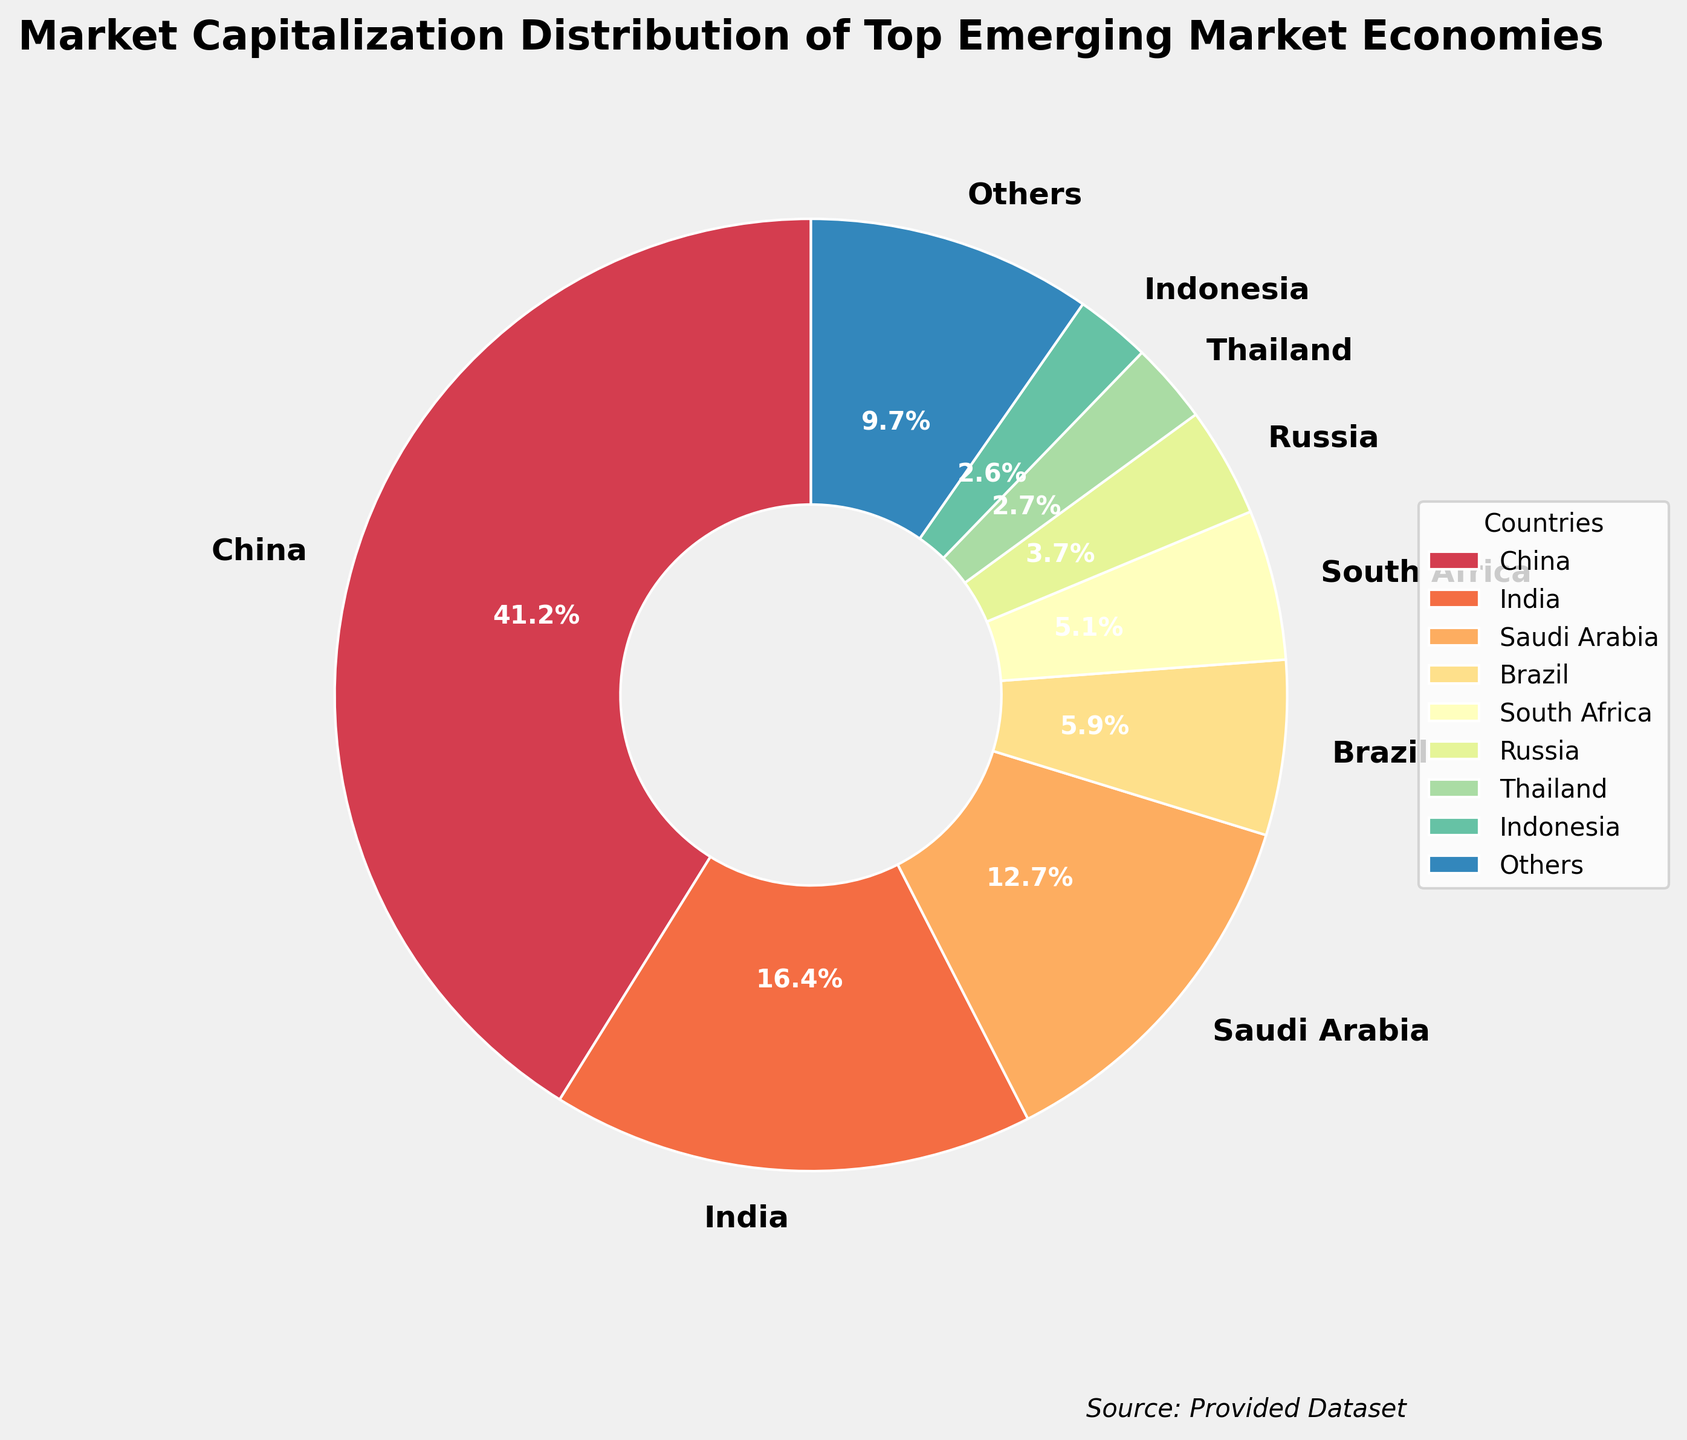What's the total percentage represented by China and India? China represents 40.5% and India represents 16.1%. Adding these percentages together: 40.5% + 16.1% = 56.6%.
Answer: 56.6% Which country has the smallest share among the top 8 countries? The country with the smallest share among the top 8 is Indonesia, which represents 2.5%. By checking the pie chart, this is clearly seen from the labeled percentages.
Answer: Indonesia How does Brazil's market capitalization compare to that of Saudi Arabia? Brazil's market capitalization is 5.8%, while Saudi Arabia's is 12.5%. Therefore, Saudi Arabia has more than double the percentage of Brazil's market capitalization.
Answer: Saudi Arabia is greater What percentage do the 'Others' category account for? By summing up the percentages of the top 8 countries and subtracting from 100%, we find 'Others'. Adding these values: 40.5% (China) + 16.1% (India) + 12.5% (Saudi Arabia) + 5.8% (Brazil) + 4.9% (South Africa) + 3.7% (Russia) + 2.5% (Indonesia) + 2.3% (Thailand) gives 88.3%. So, 100% - 88.3% = 11.7%.
Answer: 11.7% Identify the country represented by the second largest segment in the pie chart The second-largest segment in the pie chart corresponds to India, which accounts for 16.1% of the market capitalization among the top emerging market economies.
Answer: India What is the combined market capitalization percentage of Brazil and South Africa? The market capitalization percentages for Brazil and South Africa are 5.8% and 4.9% respectively. Adding these values together: 5.8% + 4.9% = 10.7%.
Answer: 10.7% How does South Africa's market capitalization percentage compare visually to Russia? South Africa's segment of 4.9% is visually larger than Russia's segment of 3.7%, making it clear that South Africa has a larger market capitalization percentage in the pie chart.
Answer: South Africa is greater Is Saudi Arabia's market capitalization less than 15% of the total? By looking at the pie chart, Saudi Arabia's market capitalization is shown as 12.5%, which is indeed less than 15%.
Answer: Yes Which countries have a market capitalization percentage that is less than 3% each? From the pie chart, Indonesia (2.5%) and Thailand (2.3%) have market capitalization percentages that are each less than 3%.
Answer: Indonesia, Thailand 